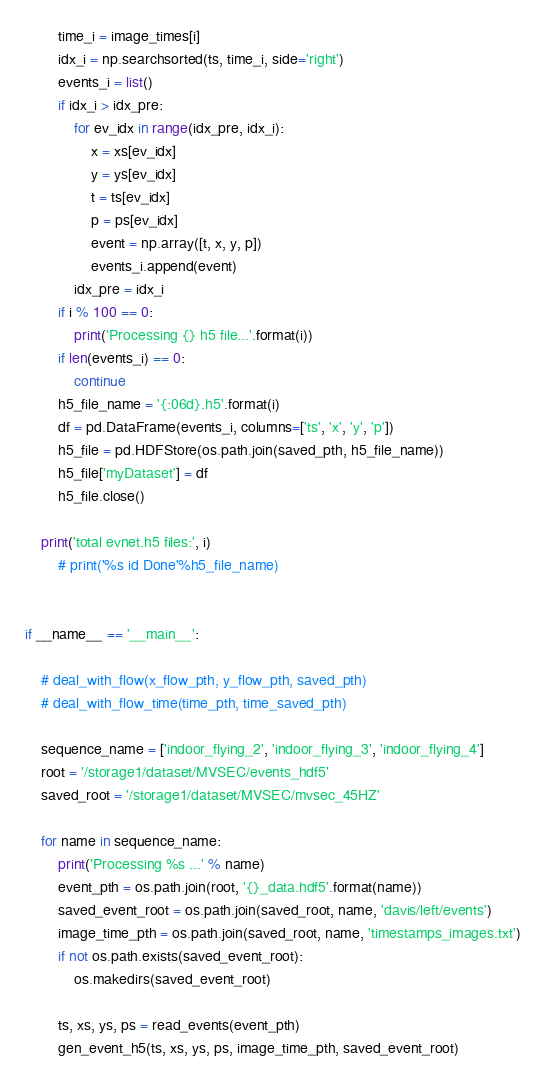<code> <loc_0><loc_0><loc_500><loc_500><_Python_>        time_i = image_times[i]
        idx_i = np.searchsorted(ts, time_i, side='right')
        events_i = list()
        if idx_i > idx_pre:
            for ev_idx in range(idx_pre, idx_i):
                x = xs[ev_idx]
                y = ys[ev_idx]
                t = ts[ev_idx]
                p = ps[ev_idx]
                event = np.array([t, x, y, p])
                events_i.append(event)
            idx_pre = idx_i
        if i % 100 == 0:
            print('Processing {} h5 file...'.format(i))
        if len(events_i) == 0:
            continue
        h5_file_name = '{:06d}.h5'.format(i)
        df = pd.DataFrame(events_i, columns=['ts', 'x', 'y', 'p'])
        h5_file = pd.HDFStore(os.path.join(saved_pth, h5_file_name))
        h5_file['myDataset'] = df
        h5_file.close()

    print('total evnet.h5 files:', i)
        # print('%s id Done'%h5_file_name)


if __name__ == '__main__':

    # deal_with_flow(x_flow_pth, y_flow_pth, saved_pth)
    # deal_with_flow_time(time_pth, time_saved_pth)

    sequence_name = ['indoor_flying_2', 'indoor_flying_3', 'indoor_flying_4']
    root = '/storage1/dataset/MVSEC/events_hdf5'
    saved_root = '/storage1/dataset/MVSEC/mvsec_45HZ'

    for name in sequence_name:
        print('Processing %s ...' % name)
        event_pth = os.path.join(root, '{}_data.hdf5'.format(name))
        saved_event_root = os.path.join(saved_root, name, 'davis/left/events')
        image_time_pth = os.path.join(saved_root, name, 'timestamps_images.txt')
        if not os.path.exists(saved_event_root):
            os.makedirs(saved_event_root)

        ts, xs, ys, ps = read_events(event_pth)
        gen_event_h5(ts, xs, ys, ps, image_time_pth, saved_event_root)</code> 